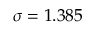Convert formula to latex. <formula><loc_0><loc_0><loc_500><loc_500>\sigma = 1 . 3 8 5</formula> 